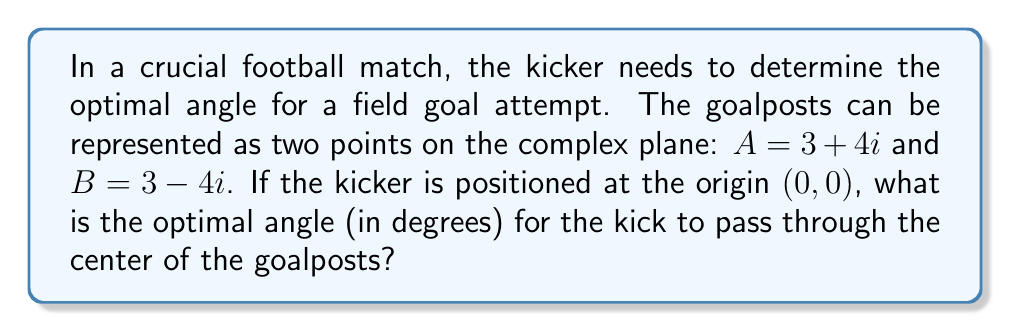Provide a solution to this math problem. Let's approach this step-by-step:

1) The center of the goalposts is the midpoint between A and B. We can find this by averaging their coordinates:

   $C = \frac{A + B}{2} = \frac{(3 + 4i) + (3 - 4i)}{2} = \frac{6 + 0i}{2} = 3$

2) So, the center of the goalposts is at the point (3, 0) on the complex plane.

3) To find the angle, we need to use the arctangent function. However, since the y-coordinate is 0, we can't directly use arctan(y/x).

4) Instead, we can use the complex argument function, arg(z), which gives us the angle between the positive real axis and the line from the origin to the point z.

5) In this case, $z = 3 + 0i = 3$

6) For a real positive number, the argument is always 0.

7) Therefore, the optimal angle is 0°.

8) This makes sense geometrically, as the kicker should aim straight ahead to hit the center of the goalposts.
Answer: 0° 